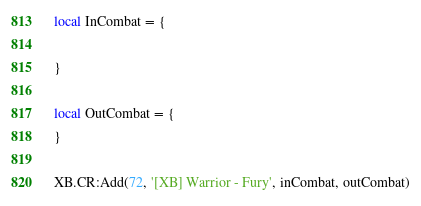Convert code to text. <code><loc_0><loc_0><loc_500><loc_500><_Lua_>local InCombat = {

}

local OutCombat = {
}

XB.CR:Add(72, '[XB] Warrior - Fury', inCombat, outCombat)</code> 